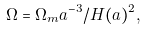Convert formula to latex. <formula><loc_0><loc_0><loc_500><loc_500>\Omega = \Omega _ { m } a ^ { - 3 } / H ( a ) ^ { 2 } ,</formula> 